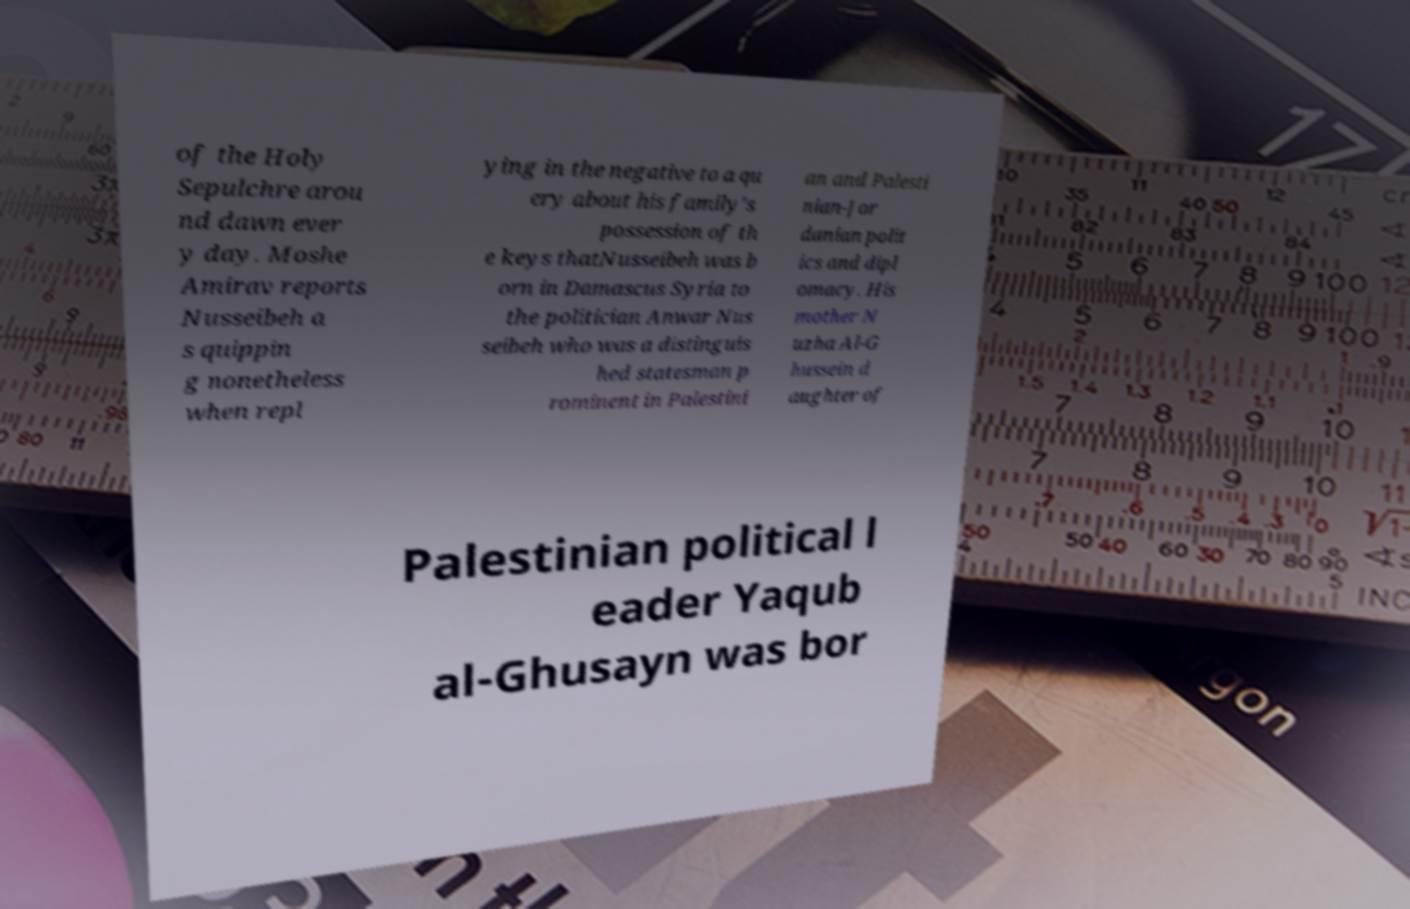Can you accurately transcribe the text from the provided image for me? of the Holy Sepulchre arou nd dawn ever y day. Moshe Amirav reports Nusseibeh a s quippin g nonetheless when repl ying in the negative to a qu ery about his family’s possession of th e keys thatNusseibeh was b orn in Damascus Syria to the politician Anwar Nus seibeh who was a distinguis hed statesman p rominent in Palestini an and Palesti nian-Jor danian polit ics and dipl omacy. His mother N uzha Al-G hussein d aughter of Palestinian political l eader Yaqub al-Ghusayn was bor 